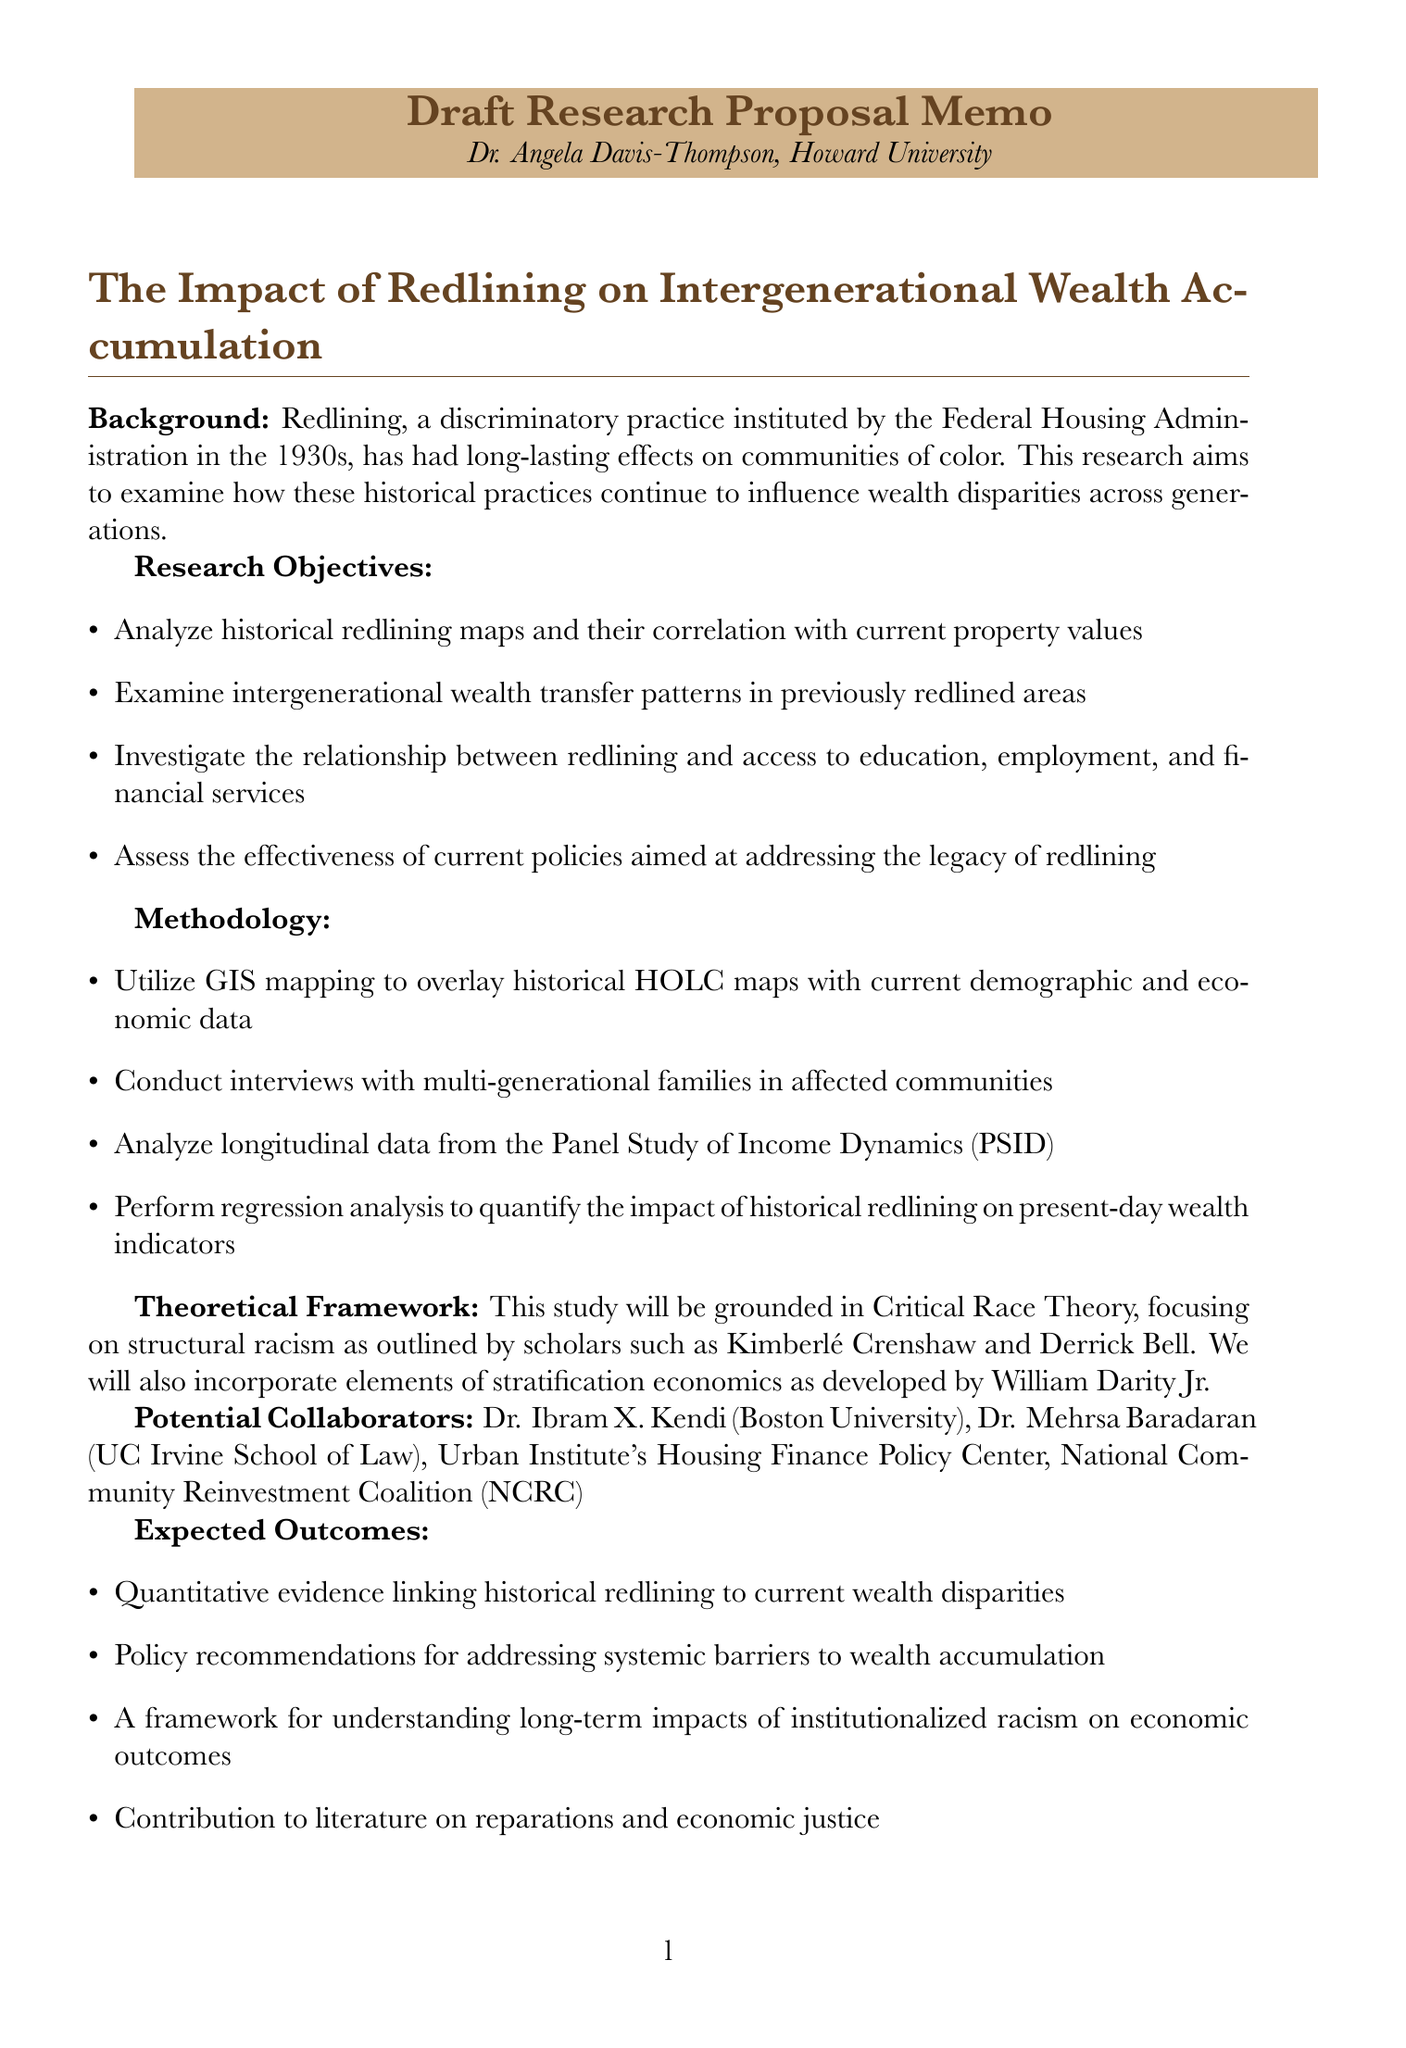What is the title of the research proposal? The title of the research proposal is explicitly stated at the beginning of the memo.
Answer: Draft Research Proposal: The Impact of Redlining on Intergenerational Wealth Accumulation Who is the author of the memo? The author's name is mentioned at the top of the document.
Answer: Dr. Angela Davis-Thompson What methodology will be used for data collection? The document specifies methods employed for gathering and analyzing data.
Answer: Utilize GIS mapping to overlay historical HOLC maps with current demographic and economic data Which theoretical framework will guide the study? The theoretical framework section outlines the foundational theory for the research.
Answer: Critical Race Theory What are the expected outcomes of the research? The expected outcomes section lists the anticipated results and contributions of the study.
Answer: Quantitative evidence linking historical redlining to current wealth disparities How long will the literature review and data collection take? The timeline section details the duration of each phase of the research project.
Answer: Months 1-3 Who are potential collaborators mentioned in the proposal? The document lists individuals and organizations that could potentially collaborate on the project.
Answer: Dr. Ibram X. Kendi, Dr. Mehrsa Baradaran, Urban Institute's Housing Finance Policy Center, National Community Reinvestment Coalition (NCRC) Which foundation is identified as a funding source? The funding sources section provides a list of potential financial backers for the research.
Answer: Ford Foundation What type of data will be analyzed from the Panel Study of Income Dynamics? The methodology outlines specific data sets that will be the focus of analysis throughout the research project.
Answer: Longitudinal data 